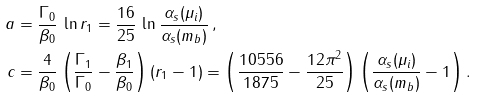Convert formula to latex. <formula><loc_0><loc_0><loc_500><loc_500>a & = \frac { \Gamma _ { 0 } } { \beta _ { 0 } } \, \ln r _ { 1 } = \frac { 1 6 } { 2 5 } \, \ln \frac { \alpha _ { s } ( \mu _ { i } ) } { \alpha _ { s } ( m _ { b } ) } \, , \\ c & = \frac { 4 } { \beta _ { 0 } } \left ( \frac { \Gamma _ { 1 } } { \Gamma _ { 0 } } - \frac { \beta _ { 1 } } { \beta _ { 0 } } \right ) ( r _ { 1 } - 1 ) = \left ( \frac { 1 0 5 5 6 } { 1 8 7 5 } - \frac { 1 2 \pi ^ { 2 } } { 2 5 } \right ) \left ( \frac { \alpha _ { s } ( \mu _ { i } ) } { \alpha _ { s } ( m _ { b } ) } - 1 \right ) .</formula> 